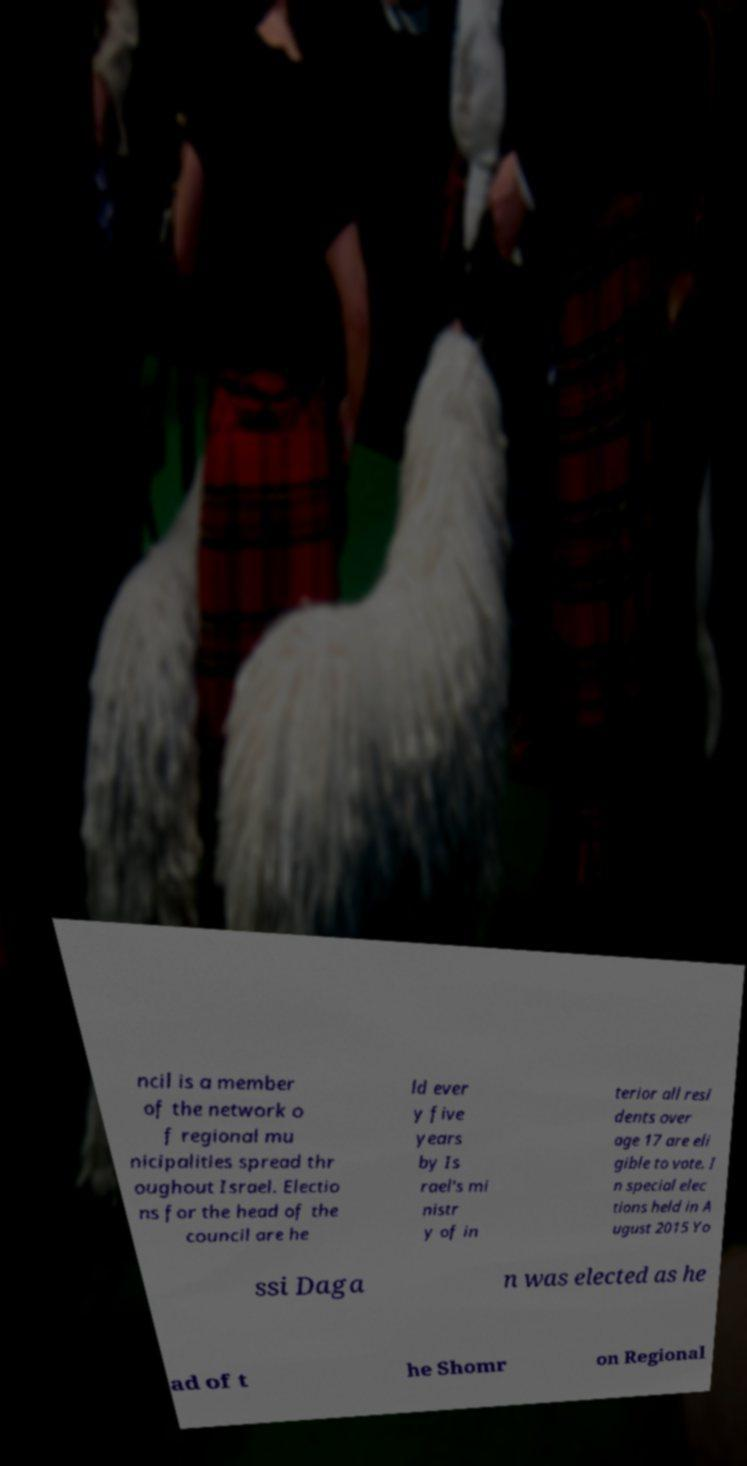Please identify and transcribe the text found in this image. ncil is a member of the network o f regional mu nicipalities spread thr oughout Israel. Electio ns for the head of the council are he ld ever y five years by Is rael's mi nistr y of in terior all resi dents over age 17 are eli gible to vote. I n special elec tions held in A ugust 2015 Yo ssi Daga n was elected as he ad of t he Shomr on Regional 